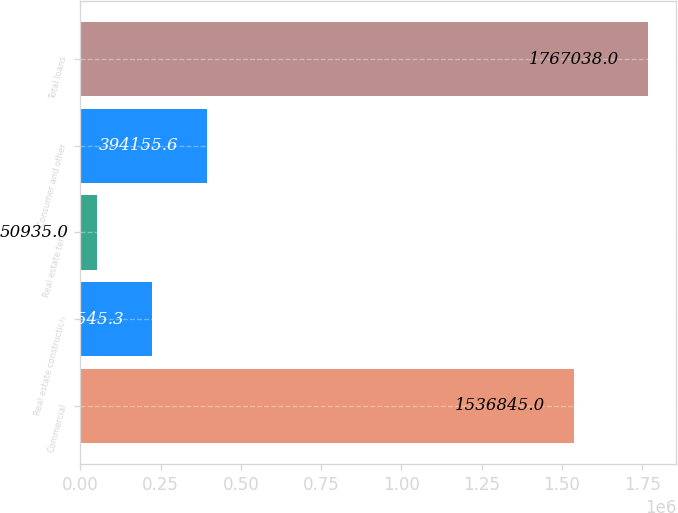<chart> <loc_0><loc_0><loc_500><loc_500><bar_chart><fcel>Commercial<fcel>Real estate construction<fcel>Real estate term<fcel>Consumer and other<fcel>Total loans<nl><fcel>1.53684e+06<fcel>222545<fcel>50935<fcel>394156<fcel>1.76704e+06<nl></chart> 